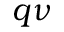<formula> <loc_0><loc_0><loc_500><loc_500>q \nu</formula> 